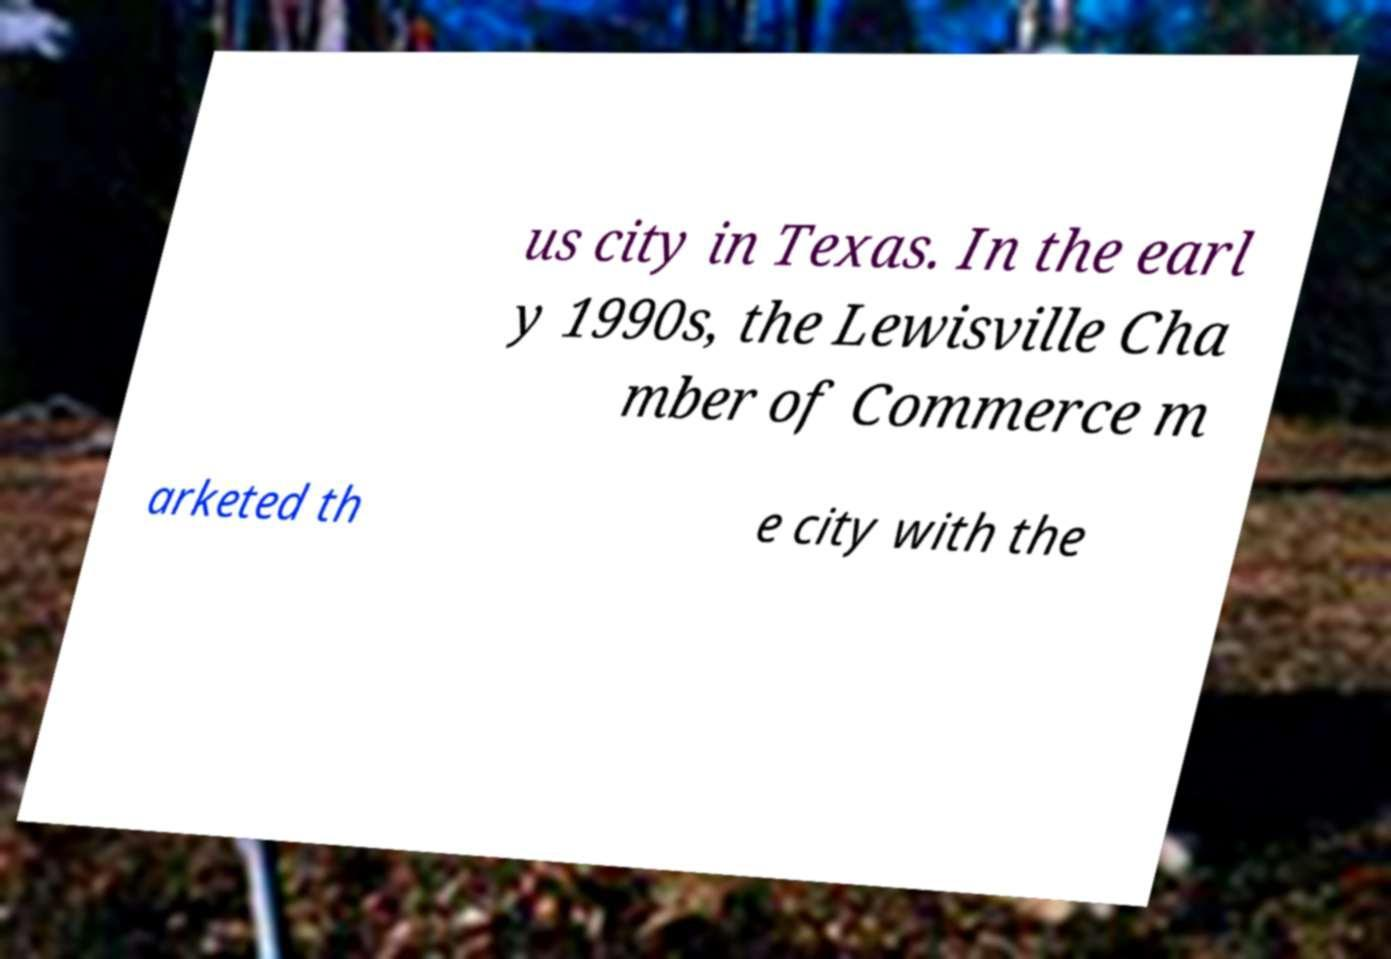Can you read and provide the text displayed in the image?This photo seems to have some interesting text. Can you extract and type it out for me? us city in Texas. In the earl y 1990s, the Lewisville Cha mber of Commerce m arketed th e city with the 